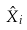<formula> <loc_0><loc_0><loc_500><loc_500>\hat { X } _ { i }</formula> 